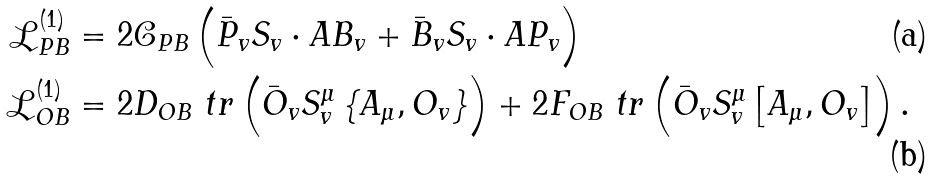Convert formula to latex. <formula><loc_0><loc_0><loc_500><loc_500>\mathcal { L } ^ { ( 1 ) } _ { P B } & = 2 \mathcal { C } _ { P B } \left ( \bar { P } _ { v } S _ { v } \cdot A B _ { v } + \bar { B } _ { v } S _ { v } \cdot A P _ { v } \right ) \\ \mathcal { L } ^ { ( 1 ) } _ { O B } & = 2 D _ { O B } \ t r \left ( \bar { O } _ { v } S ^ { \mu } _ { v } \left \{ A _ { \mu } , O _ { v } \right \} \right ) + 2 F _ { O B } \ t r \left ( \bar { O } _ { v } S ^ { \mu } _ { v } \left [ A _ { \mu } , O _ { v } \right ] \right ) .</formula> 